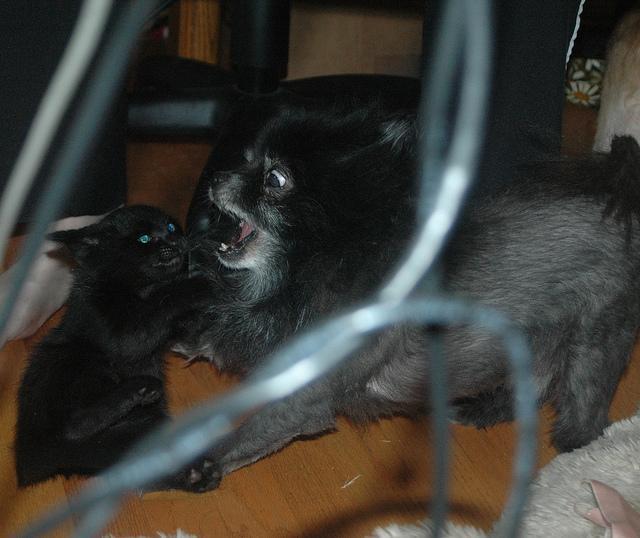How many pets can be seen?
Give a very brief answer. 2. How many horses are paying attention to the woman?
Give a very brief answer. 0. 